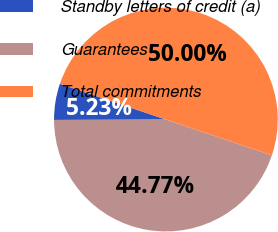Convert chart to OTSL. <chart><loc_0><loc_0><loc_500><loc_500><pie_chart><fcel>Standby letters of credit (a)<fcel>Guarantees<fcel>Total commitments<nl><fcel>5.23%<fcel>44.77%<fcel>50.0%<nl></chart> 